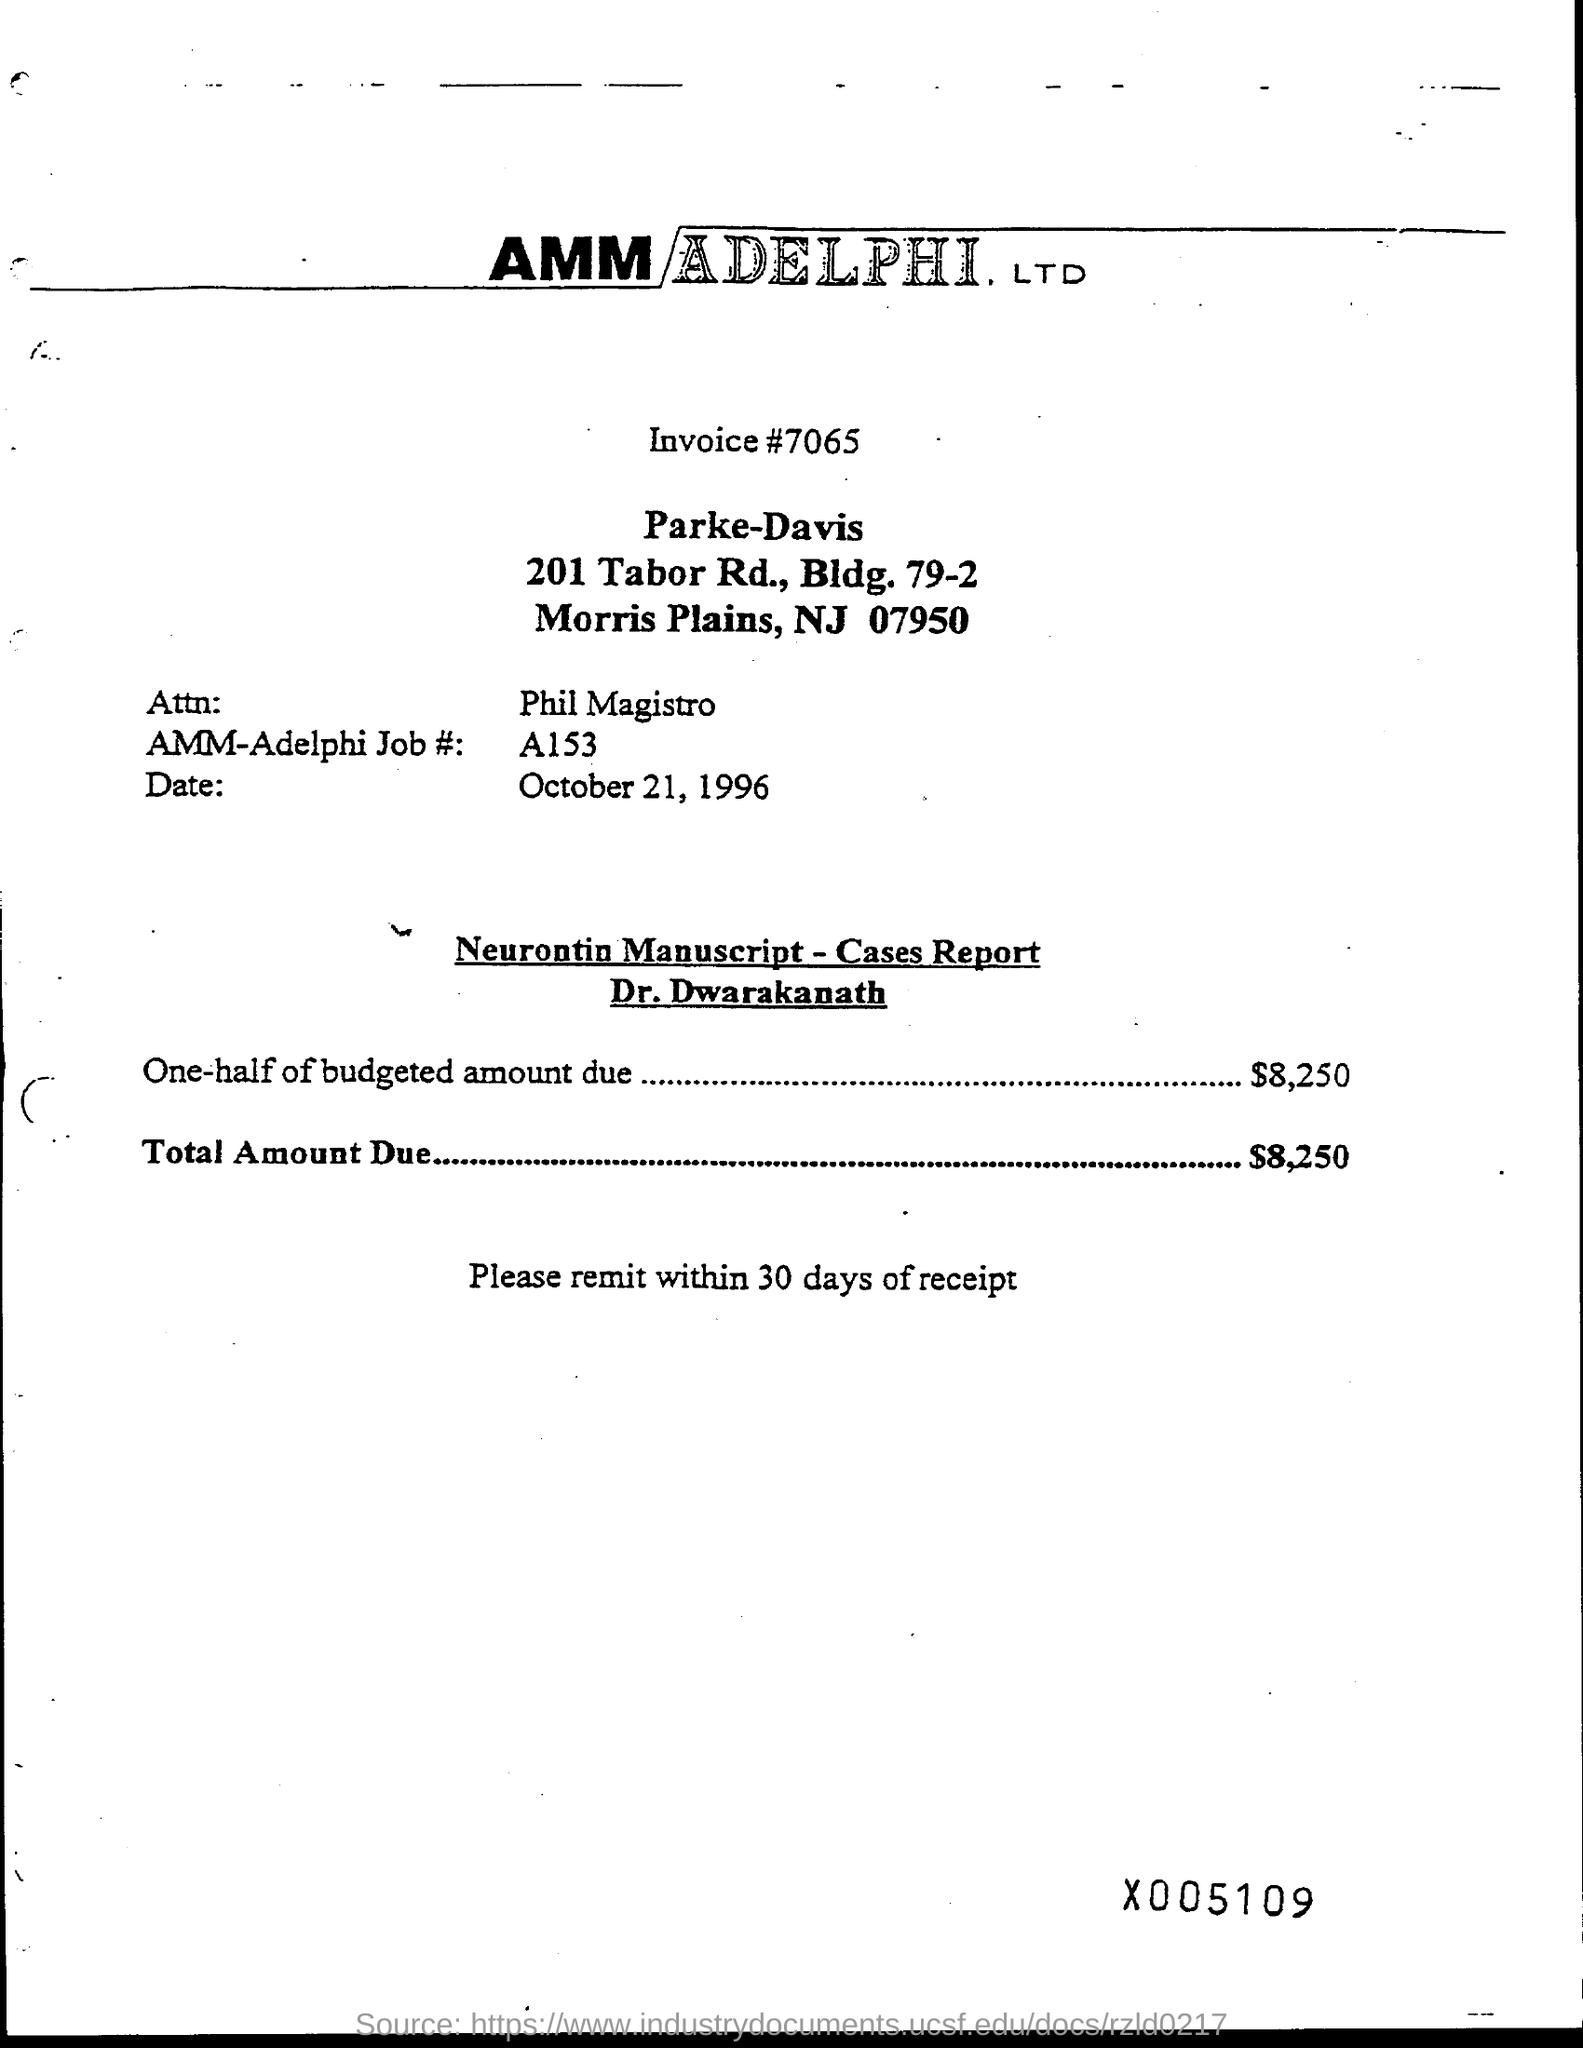Highlight a few significant elements in this photo. The invoice number mentioned in the document is 7065. The AMM-Adelphi Job# mentioned in the invoice is A153. The total amount due, as stated on the invoice, is $8,250. The date of the invoice given is October 21, 1996. The budgeted amount due mentioned in the invoice is half of $8,250. 